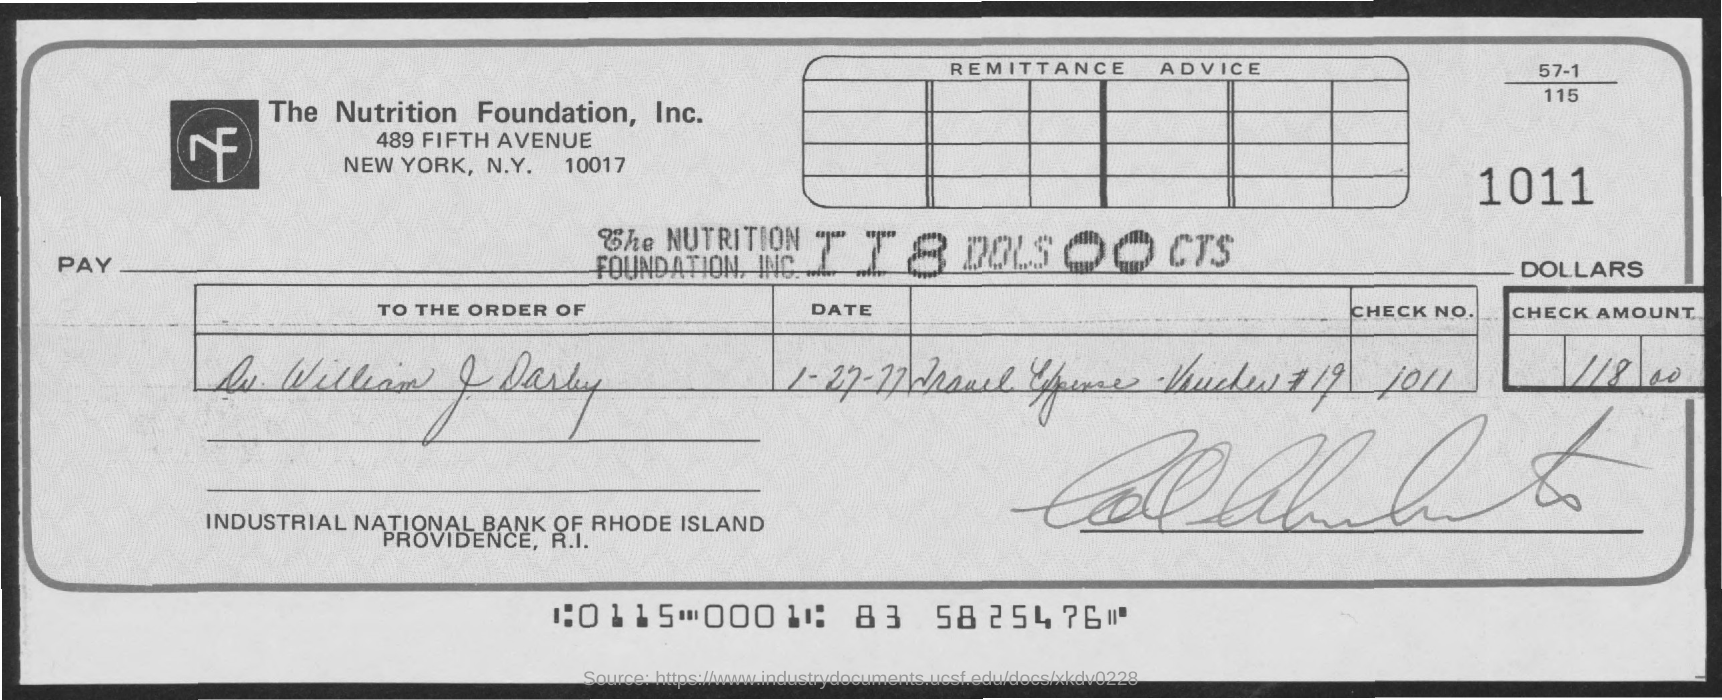What is the full-form of  nf?
Keep it short and to the point. Nutrition Foundation. To whose order is cheque paid at?
Ensure brevity in your answer.  Dr. William J. Darby. What amount is the cheque for ?
Ensure brevity in your answer.  118 Dols 00 cts. 